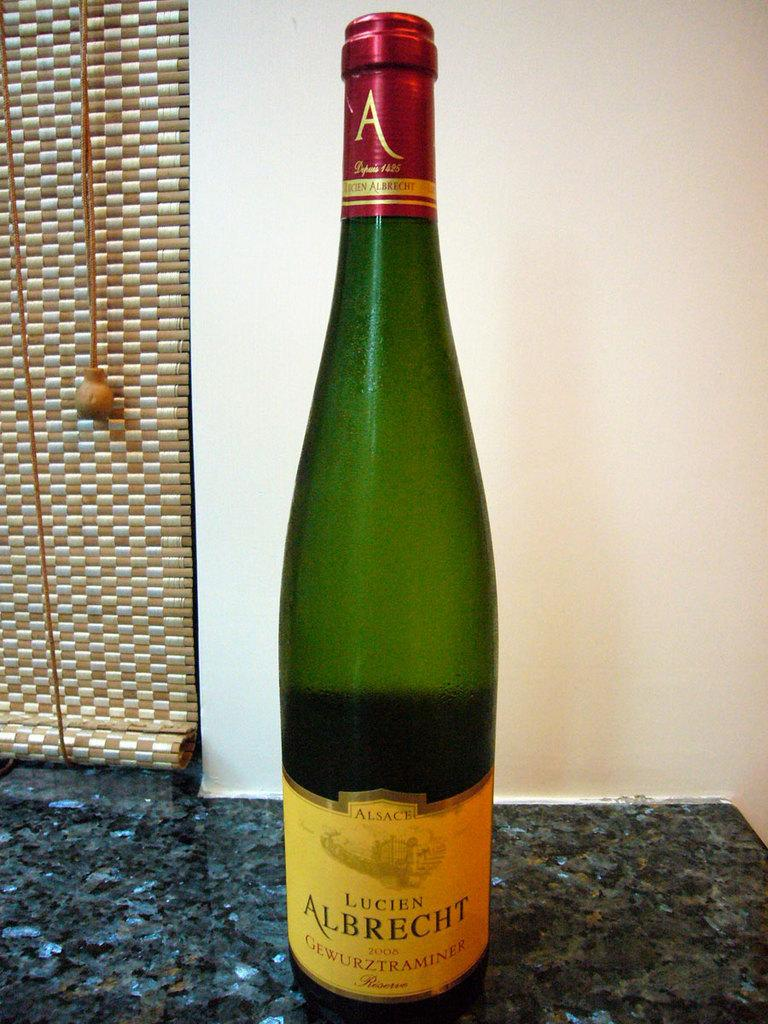Provide a one-sentence caption for the provided image. A bottle of  Lucien Albrecht 2208 on a granite counter top. 